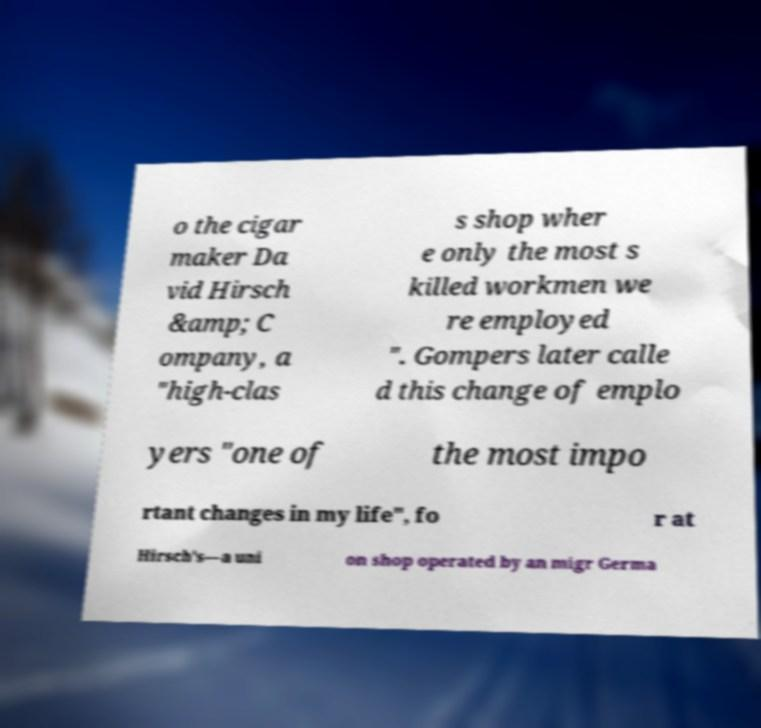What messages or text are displayed in this image? I need them in a readable, typed format. o the cigar maker Da vid Hirsch &amp; C ompany, a "high-clas s shop wher e only the most s killed workmen we re employed ". Gompers later calle d this change of emplo yers "one of the most impo rtant changes in my life", fo r at Hirsch's—a uni on shop operated by an migr Germa 